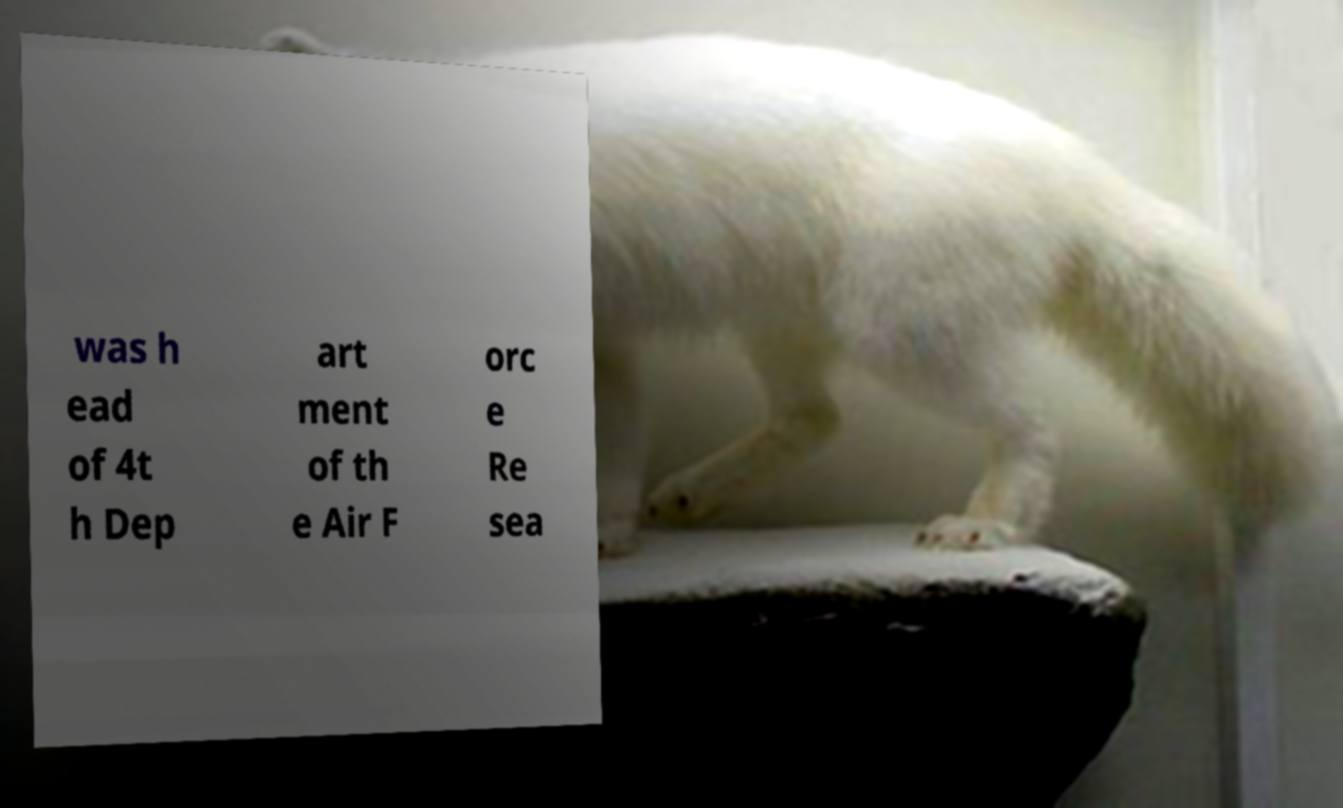I need the written content from this picture converted into text. Can you do that? was h ead of 4t h Dep art ment of th e Air F orc e Re sea 